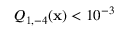Convert formula to latex. <formula><loc_0><loc_0><loc_500><loc_500>Q _ { 1 , - 4 } ( x ) < 1 0 ^ { - 3 }</formula> 